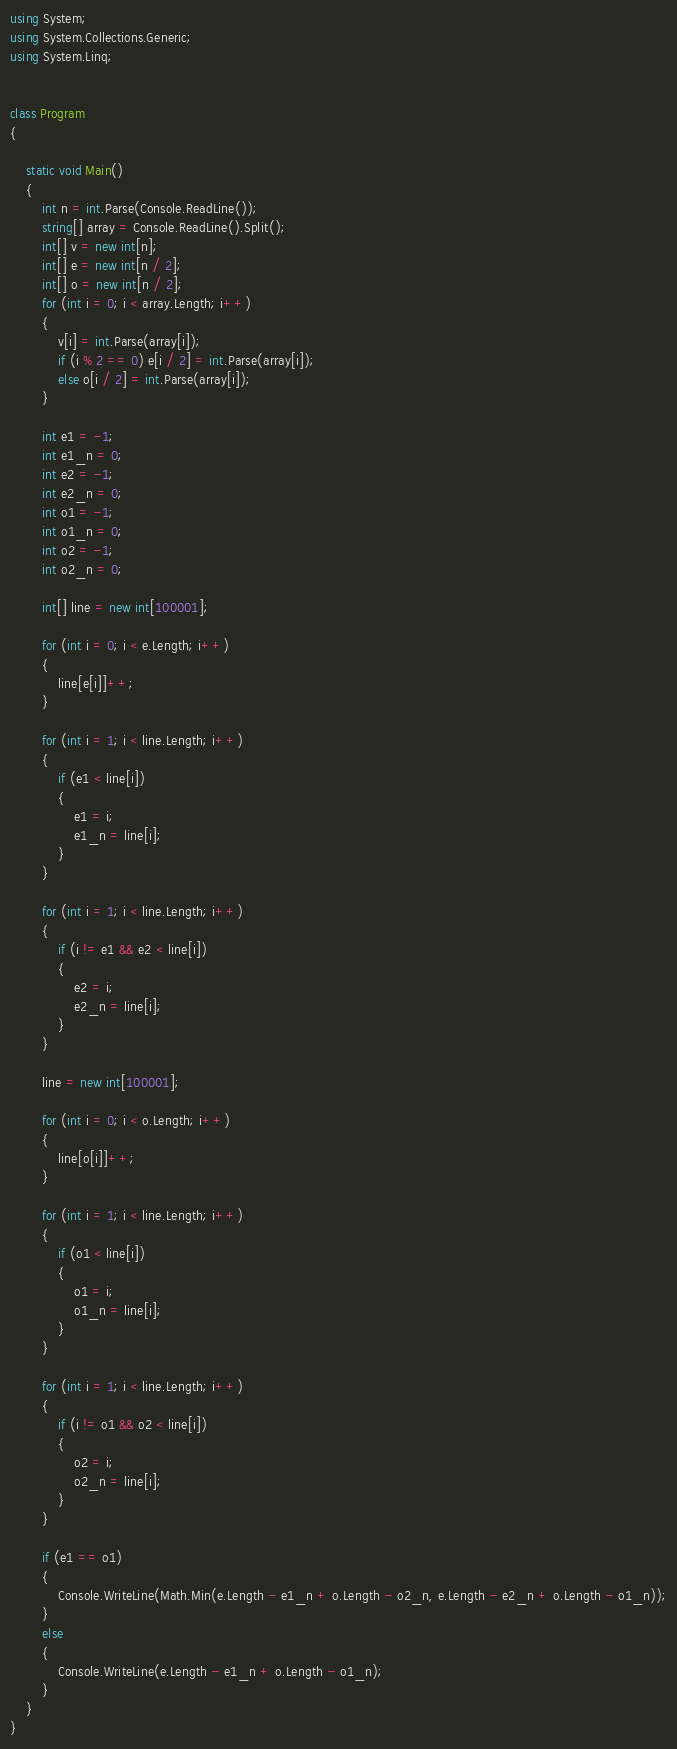Convert code to text. <code><loc_0><loc_0><loc_500><loc_500><_C#_>using System;
using System.Collections.Generic;
using System.Linq;


class Program
{

    static void Main()
    {
        int n = int.Parse(Console.ReadLine());
        string[] array = Console.ReadLine().Split();
        int[] v = new int[n];
        int[] e = new int[n / 2];
        int[] o = new int[n / 2];
        for (int i = 0; i < array.Length; i++)
        {
            v[i] = int.Parse(array[i]);
            if (i % 2 == 0) e[i / 2] = int.Parse(array[i]);
            else o[i / 2] = int.Parse(array[i]);
        }

        int e1 = -1;
        int e1_n = 0;
        int e2 = -1;
        int e2_n = 0;
        int o1 = -1;
        int o1_n = 0;
        int o2 = -1;
        int o2_n = 0;

        int[] line = new int[100001];

        for (int i = 0; i < e.Length; i++)
        {
            line[e[i]]++;
        }

        for (int i = 1; i < line.Length; i++)
        {
            if (e1 < line[i])
            {
                e1 = i;
                e1_n = line[i];
            }
        }

        for (int i = 1; i < line.Length; i++)
        {
            if (i != e1 && e2 < line[i])
            {
                e2 = i;
                e2_n = line[i];
            }
        }

        line = new int[100001];

        for (int i = 0; i < o.Length; i++)
        {
            line[o[i]]++;
        }

        for (int i = 1; i < line.Length; i++)
        {
            if (o1 < line[i])
            {
                o1 = i;
                o1_n = line[i];
            }
        }

        for (int i = 1; i < line.Length; i++)
        {
            if (i != o1 && o2 < line[i])
            {
                o2 = i;
                o2_n = line[i];
            }
        }

        if (e1 == o1)
        {
            Console.WriteLine(Math.Min(e.Length - e1_n + o.Length - o2_n, e.Length - e2_n + o.Length - o1_n));
        }
        else
        {
            Console.WriteLine(e.Length - e1_n + o.Length - o1_n);
        }
    }
}</code> 